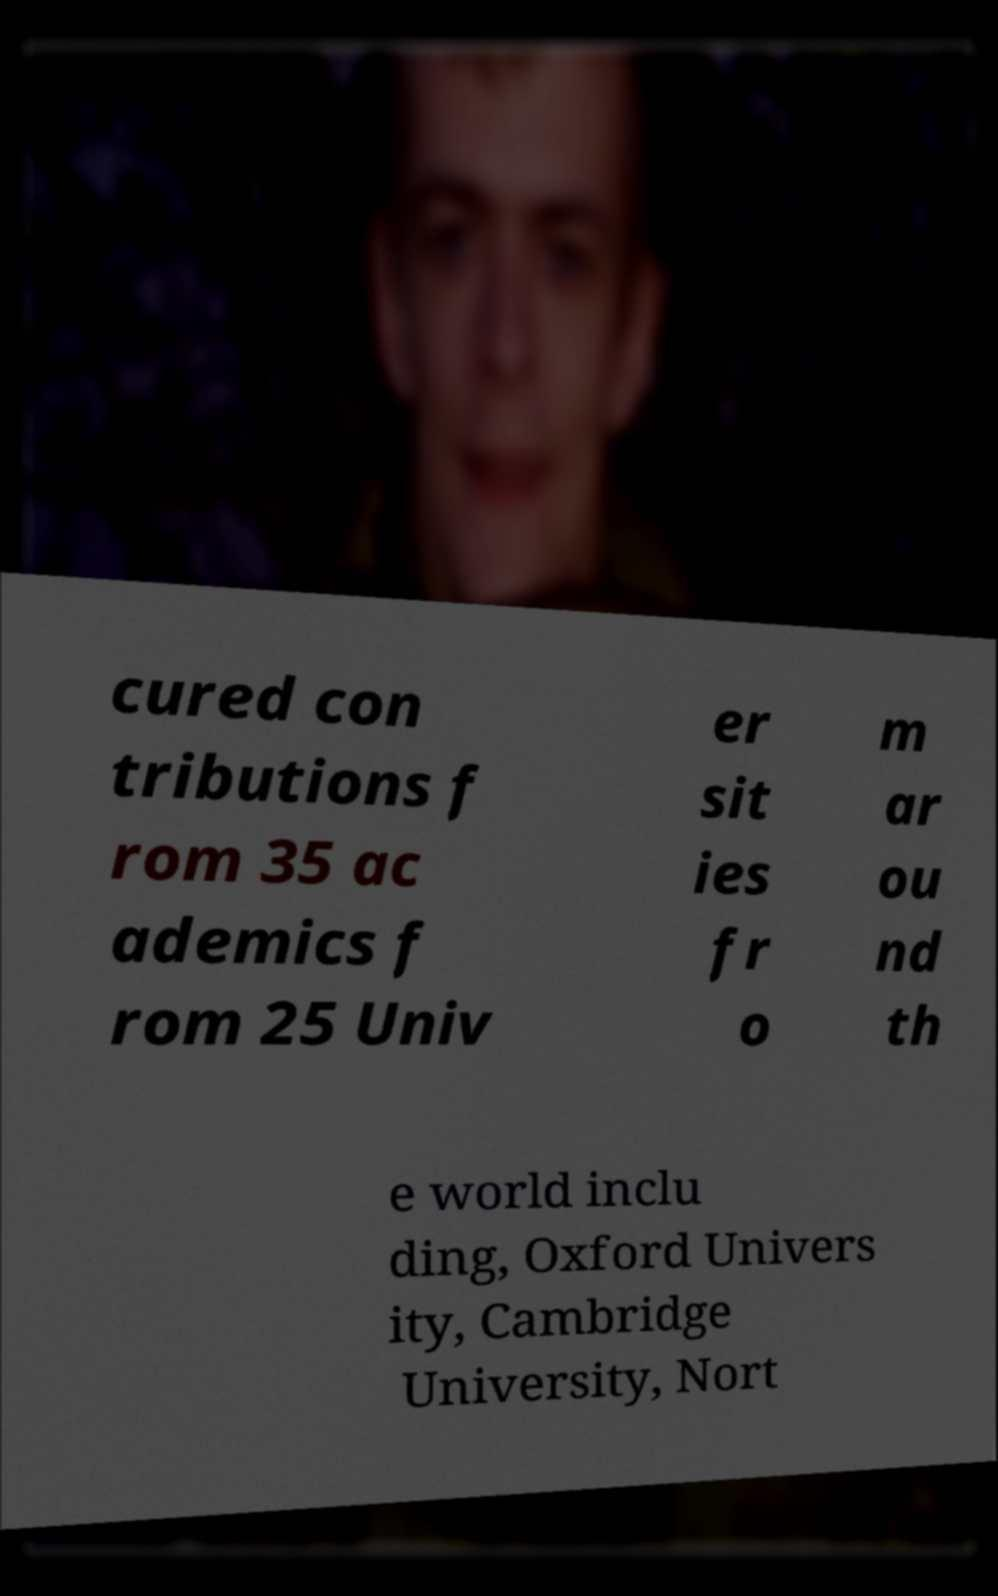Could you assist in decoding the text presented in this image and type it out clearly? cured con tributions f rom 35 ac ademics f rom 25 Univ er sit ies fr o m ar ou nd th e world inclu ding, Oxford Univers ity, Cambridge University, Nort 